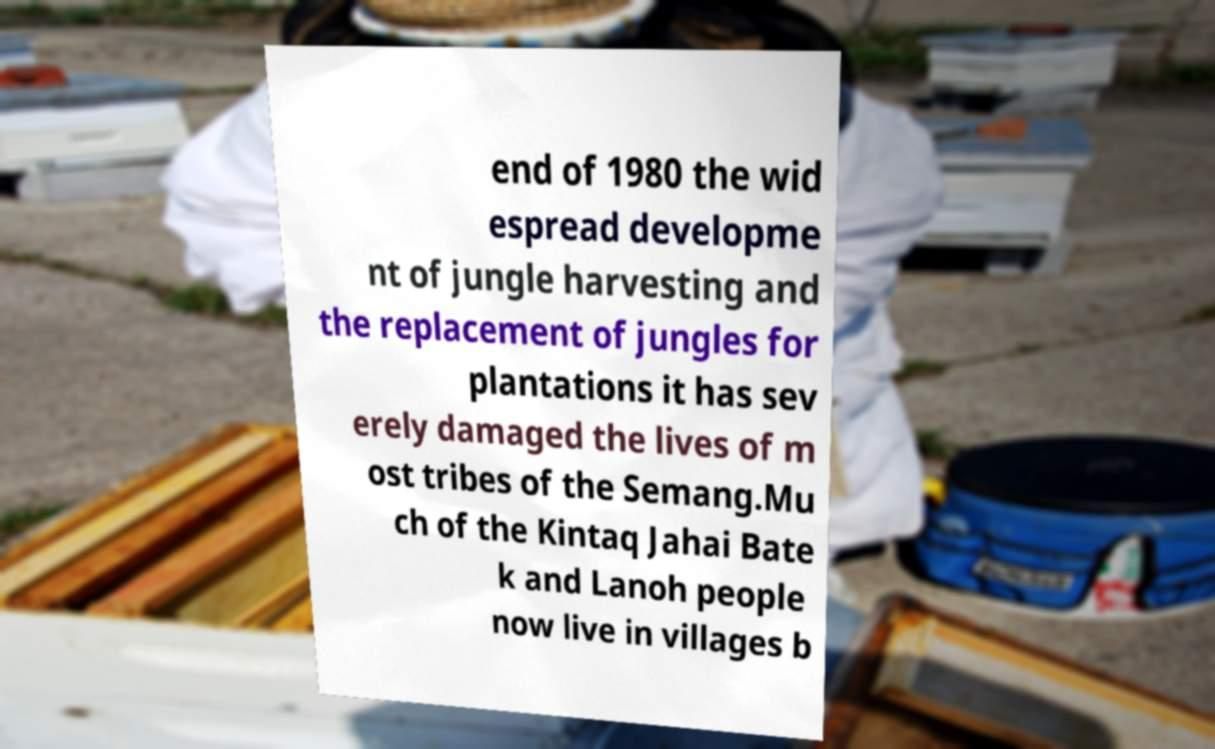There's text embedded in this image that I need extracted. Can you transcribe it verbatim? end of 1980 the wid espread developme nt of jungle harvesting and the replacement of jungles for plantations it has sev erely damaged the lives of m ost tribes of the Semang.Mu ch of the Kintaq Jahai Bate k and Lanoh people now live in villages b 